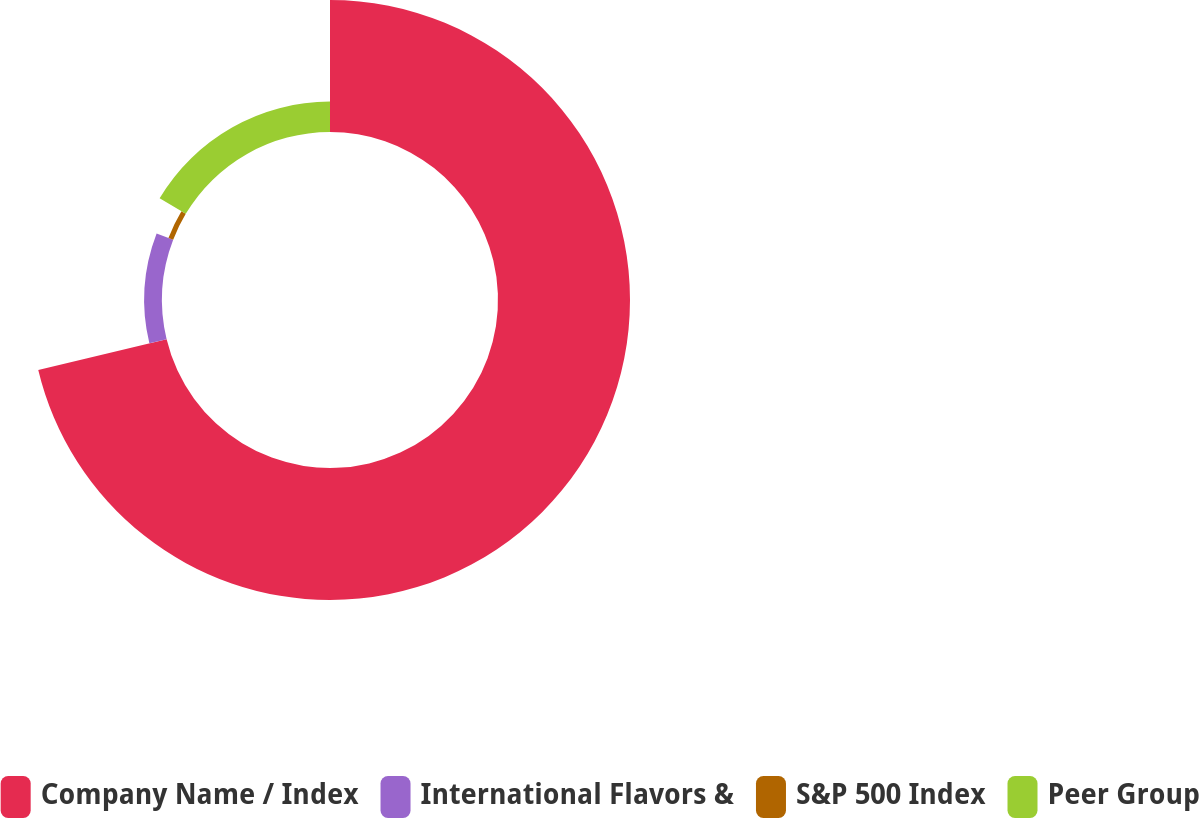Convert chart. <chart><loc_0><loc_0><loc_500><loc_500><pie_chart><fcel>Company Name / Index<fcel>International Flavors &<fcel>S&P 500 Index<fcel>Peer Group<nl><fcel>71.25%<fcel>9.58%<fcel>2.73%<fcel>16.43%<nl></chart> 